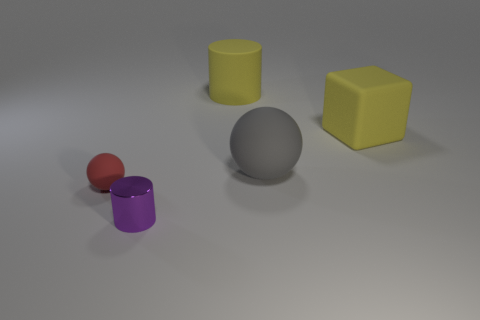Add 4 tiny rubber things. How many objects exist? 9 Subtract all blocks. How many objects are left? 4 Subtract 1 yellow cylinders. How many objects are left? 4 Subtract all cyan balls. Subtract all gray cylinders. How many balls are left? 2 Subtract all gray matte spheres. Subtract all matte cylinders. How many objects are left? 3 Add 5 big yellow matte things. How many big yellow matte things are left? 7 Add 5 tiny blue spheres. How many tiny blue spheres exist? 5 